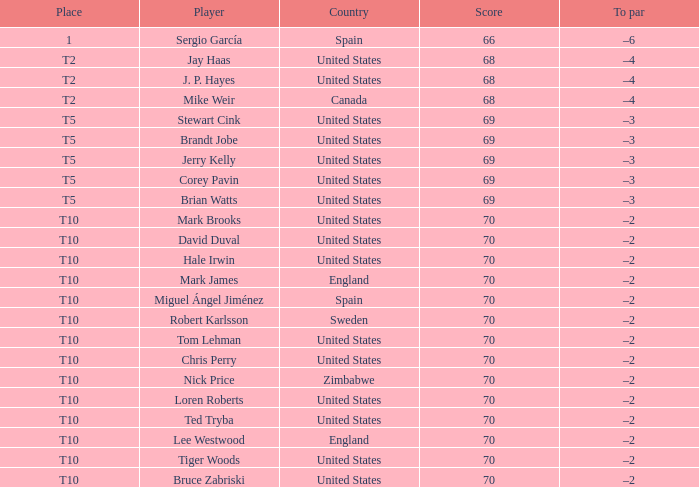Who was the player with a tally of 70? Mark Brooks, David Duval, Hale Irwin, Mark James, Miguel Ángel Jiménez, Robert Karlsson, Tom Lehman, Chris Perry, Nick Price, Loren Roberts, Ted Tryba, Lee Westwood, Tiger Woods, Bruce Zabriski. 